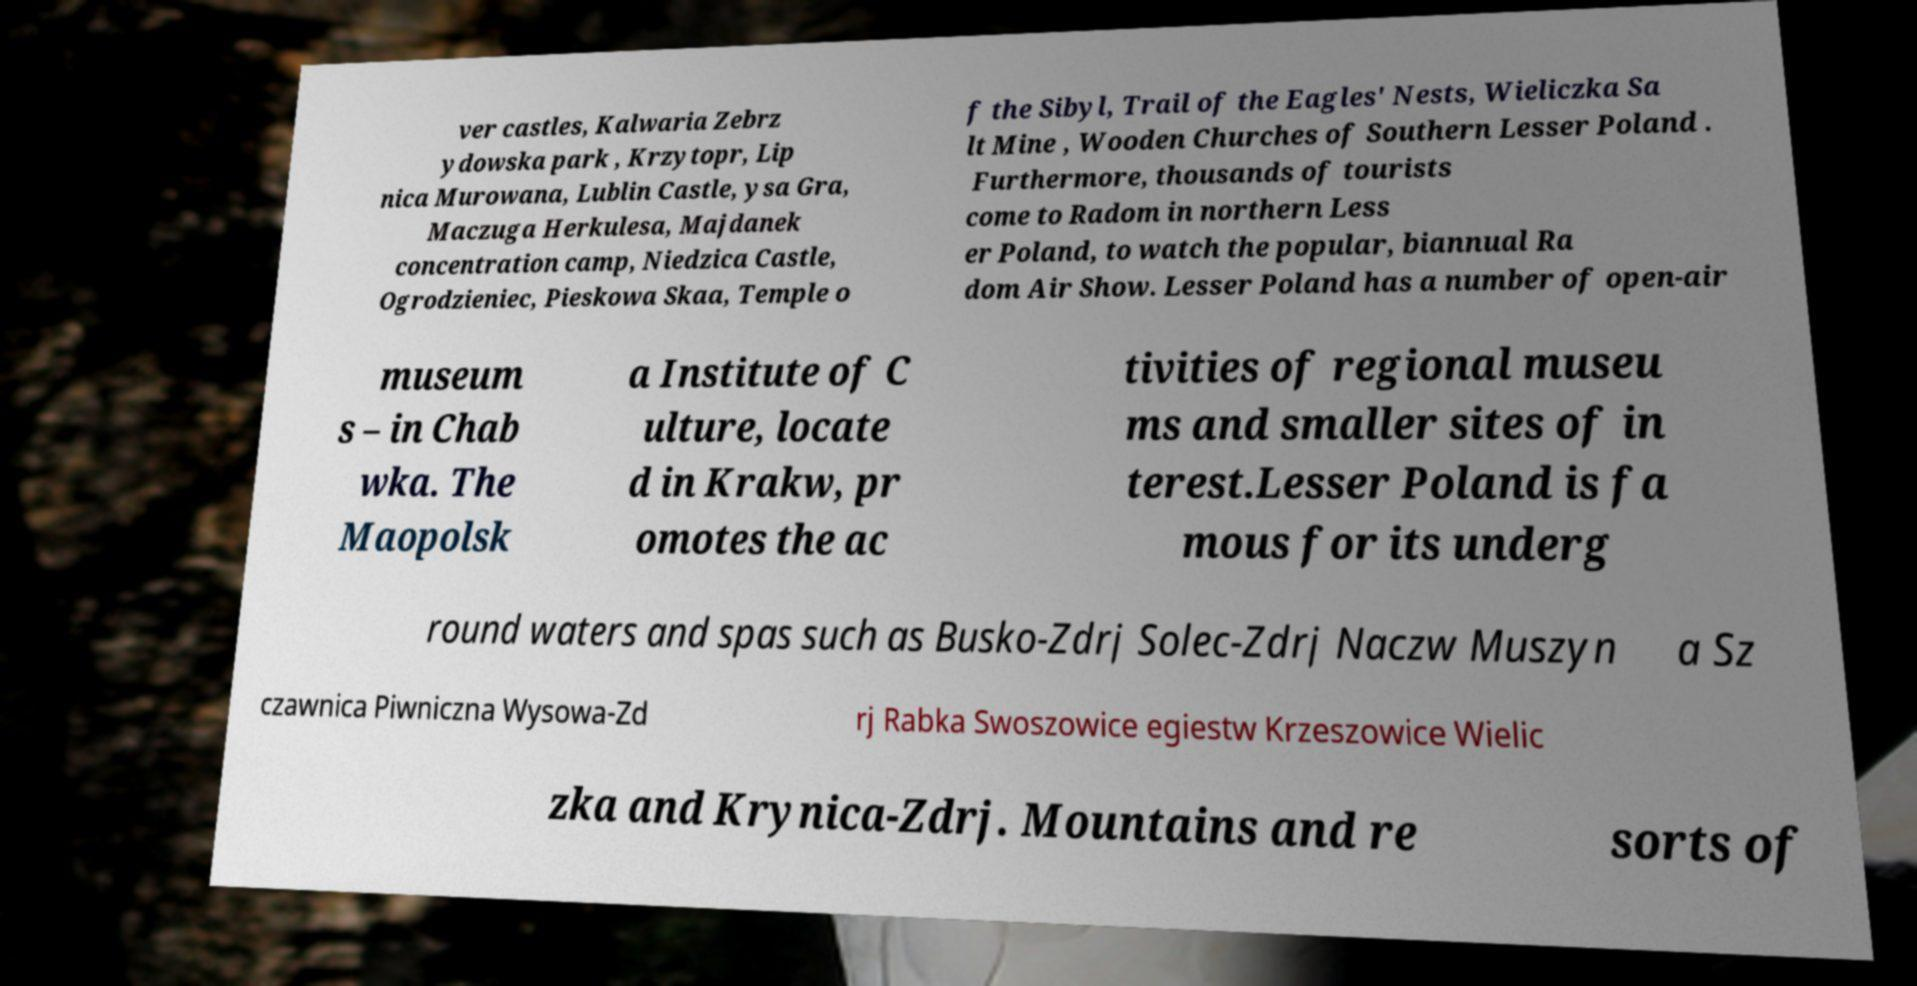I need the written content from this picture converted into text. Can you do that? ver castles, Kalwaria Zebrz ydowska park , Krzytopr, Lip nica Murowana, Lublin Castle, ysa Gra, Maczuga Herkulesa, Majdanek concentration camp, Niedzica Castle, Ogrodzieniec, Pieskowa Skaa, Temple o f the Sibyl, Trail of the Eagles' Nests, Wieliczka Sa lt Mine , Wooden Churches of Southern Lesser Poland . Furthermore, thousands of tourists come to Radom in northern Less er Poland, to watch the popular, biannual Ra dom Air Show. Lesser Poland has a number of open-air museum s – in Chab wka. The Maopolsk a Institute of C ulture, locate d in Krakw, pr omotes the ac tivities of regional museu ms and smaller sites of in terest.Lesser Poland is fa mous for its underg round waters and spas such as Busko-Zdrj Solec-Zdrj Naczw Muszyn a Sz czawnica Piwniczna Wysowa-Zd rj Rabka Swoszowice egiestw Krzeszowice Wielic zka and Krynica-Zdrj. Mountains and re sorts of 